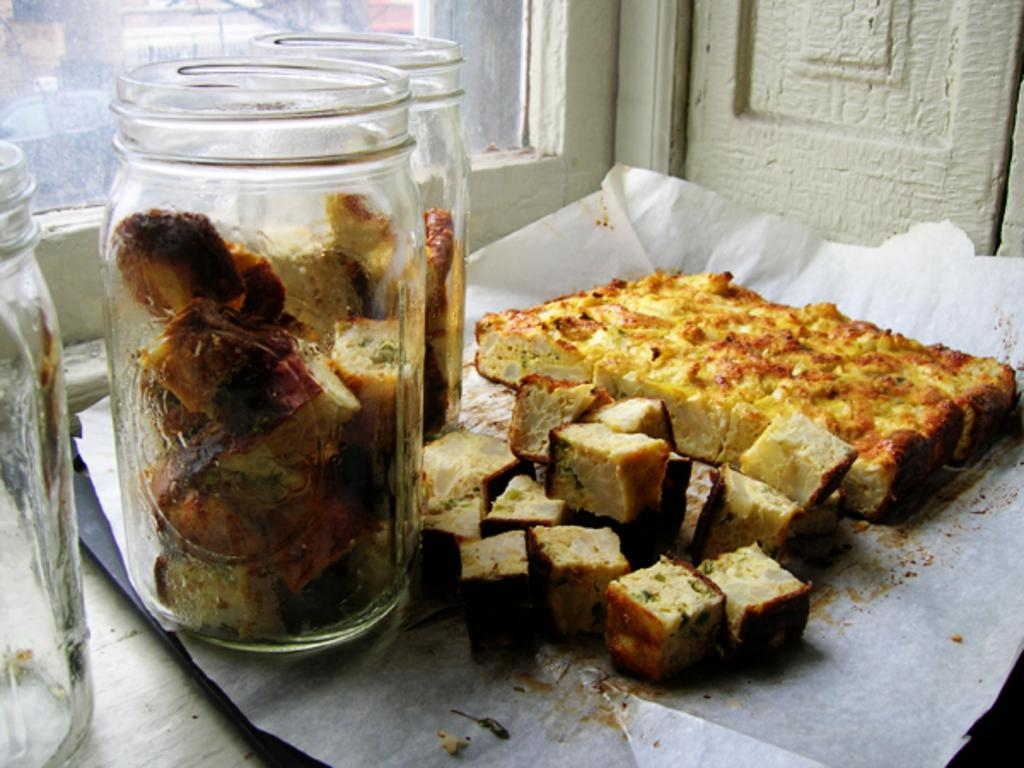What can be found in the jars in the image? There are food items in the jars in the image. What is the food item on the paper in the image? There is a food item on a paper in the image. What can be seen in the background of the image? There is a wall in the background of the image. How many chairs are visible in the image? There are no chairs present in the image. What type of books can be seen on the food item in the image? There are no books present in the image; it features jars containing food items and a food item on a paper. 